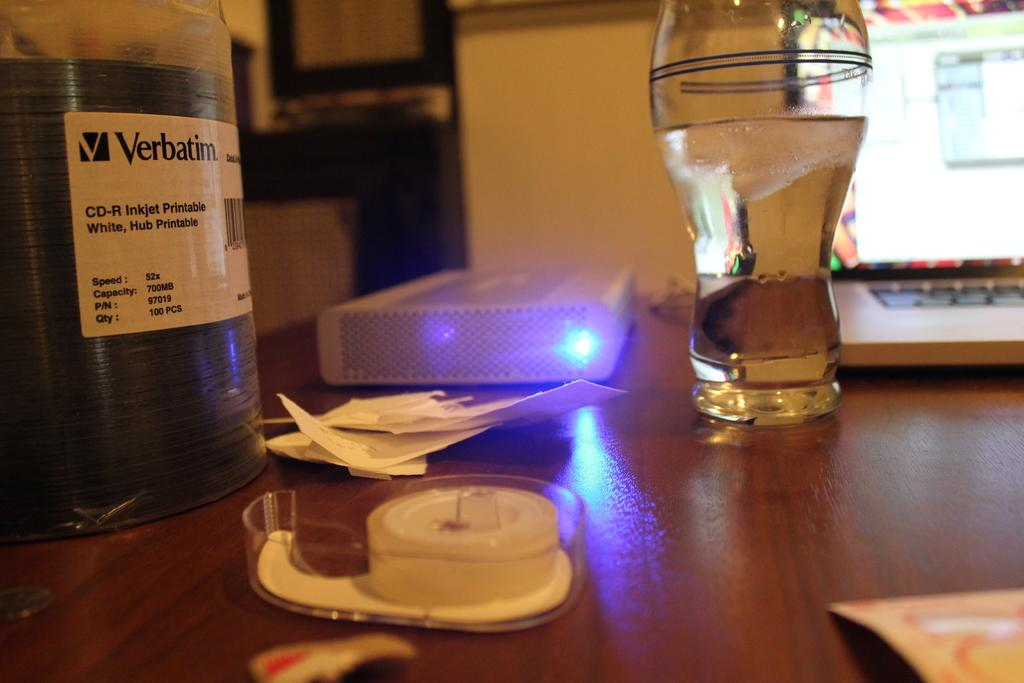What is on the table in the image? There is a glass, a laptop, and papers on the table. Can you describe any other objects on the table? There are other unspecified things on the table. What type of device is on the table? There is a laptop on the table. What might be used for writing or reading on the table? Papers are on the table, which might be used for writing or reading. Where is the father in the image? There is no father present in the image. What type of quill is being used to write on the papers? There is no quill present in the image. 